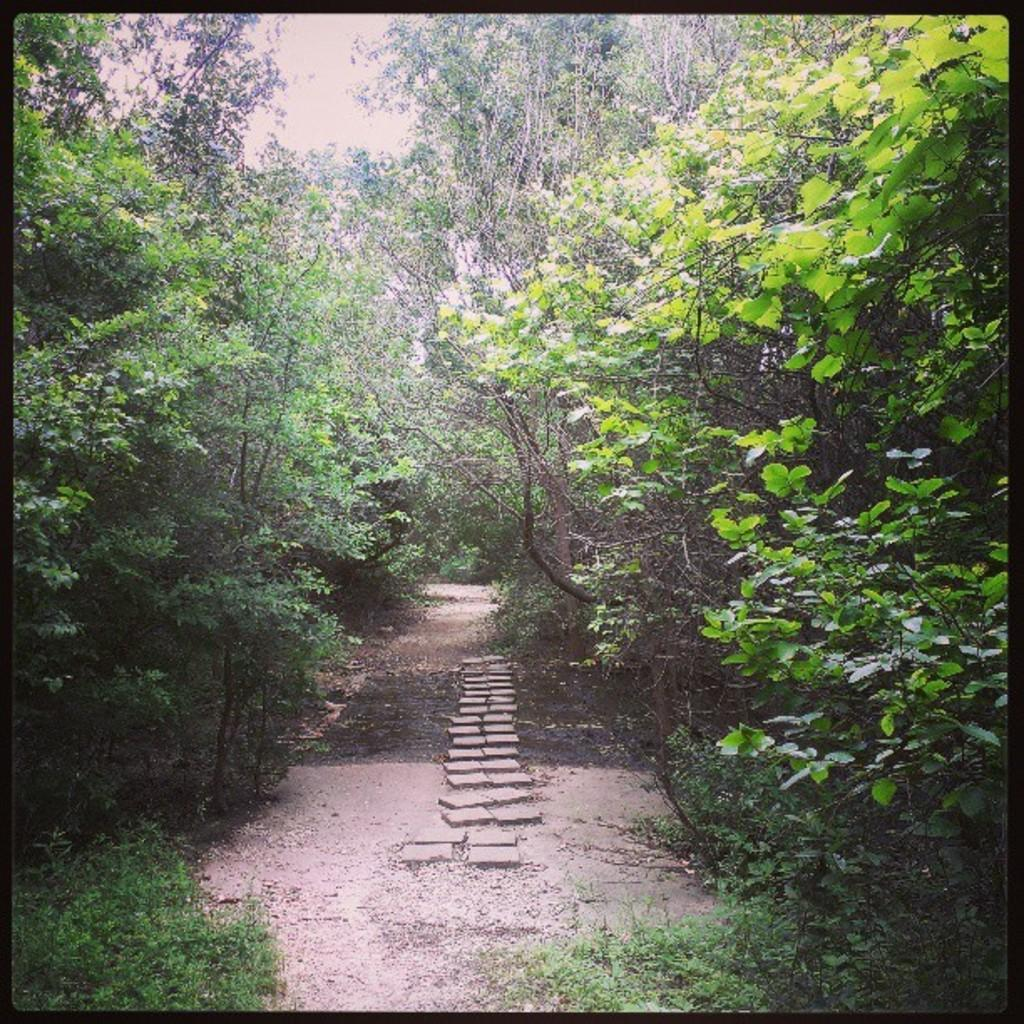What type of vegetation is present in the image? There is a group of trees in the image. What can be seen on the ground in the image? There are stones and grass visible on the ground in the image. What part of the natural environment is visible in the image? The sky is visible in the image. How many women are looking at the paste in the image? There are no women or paste present in the image. 